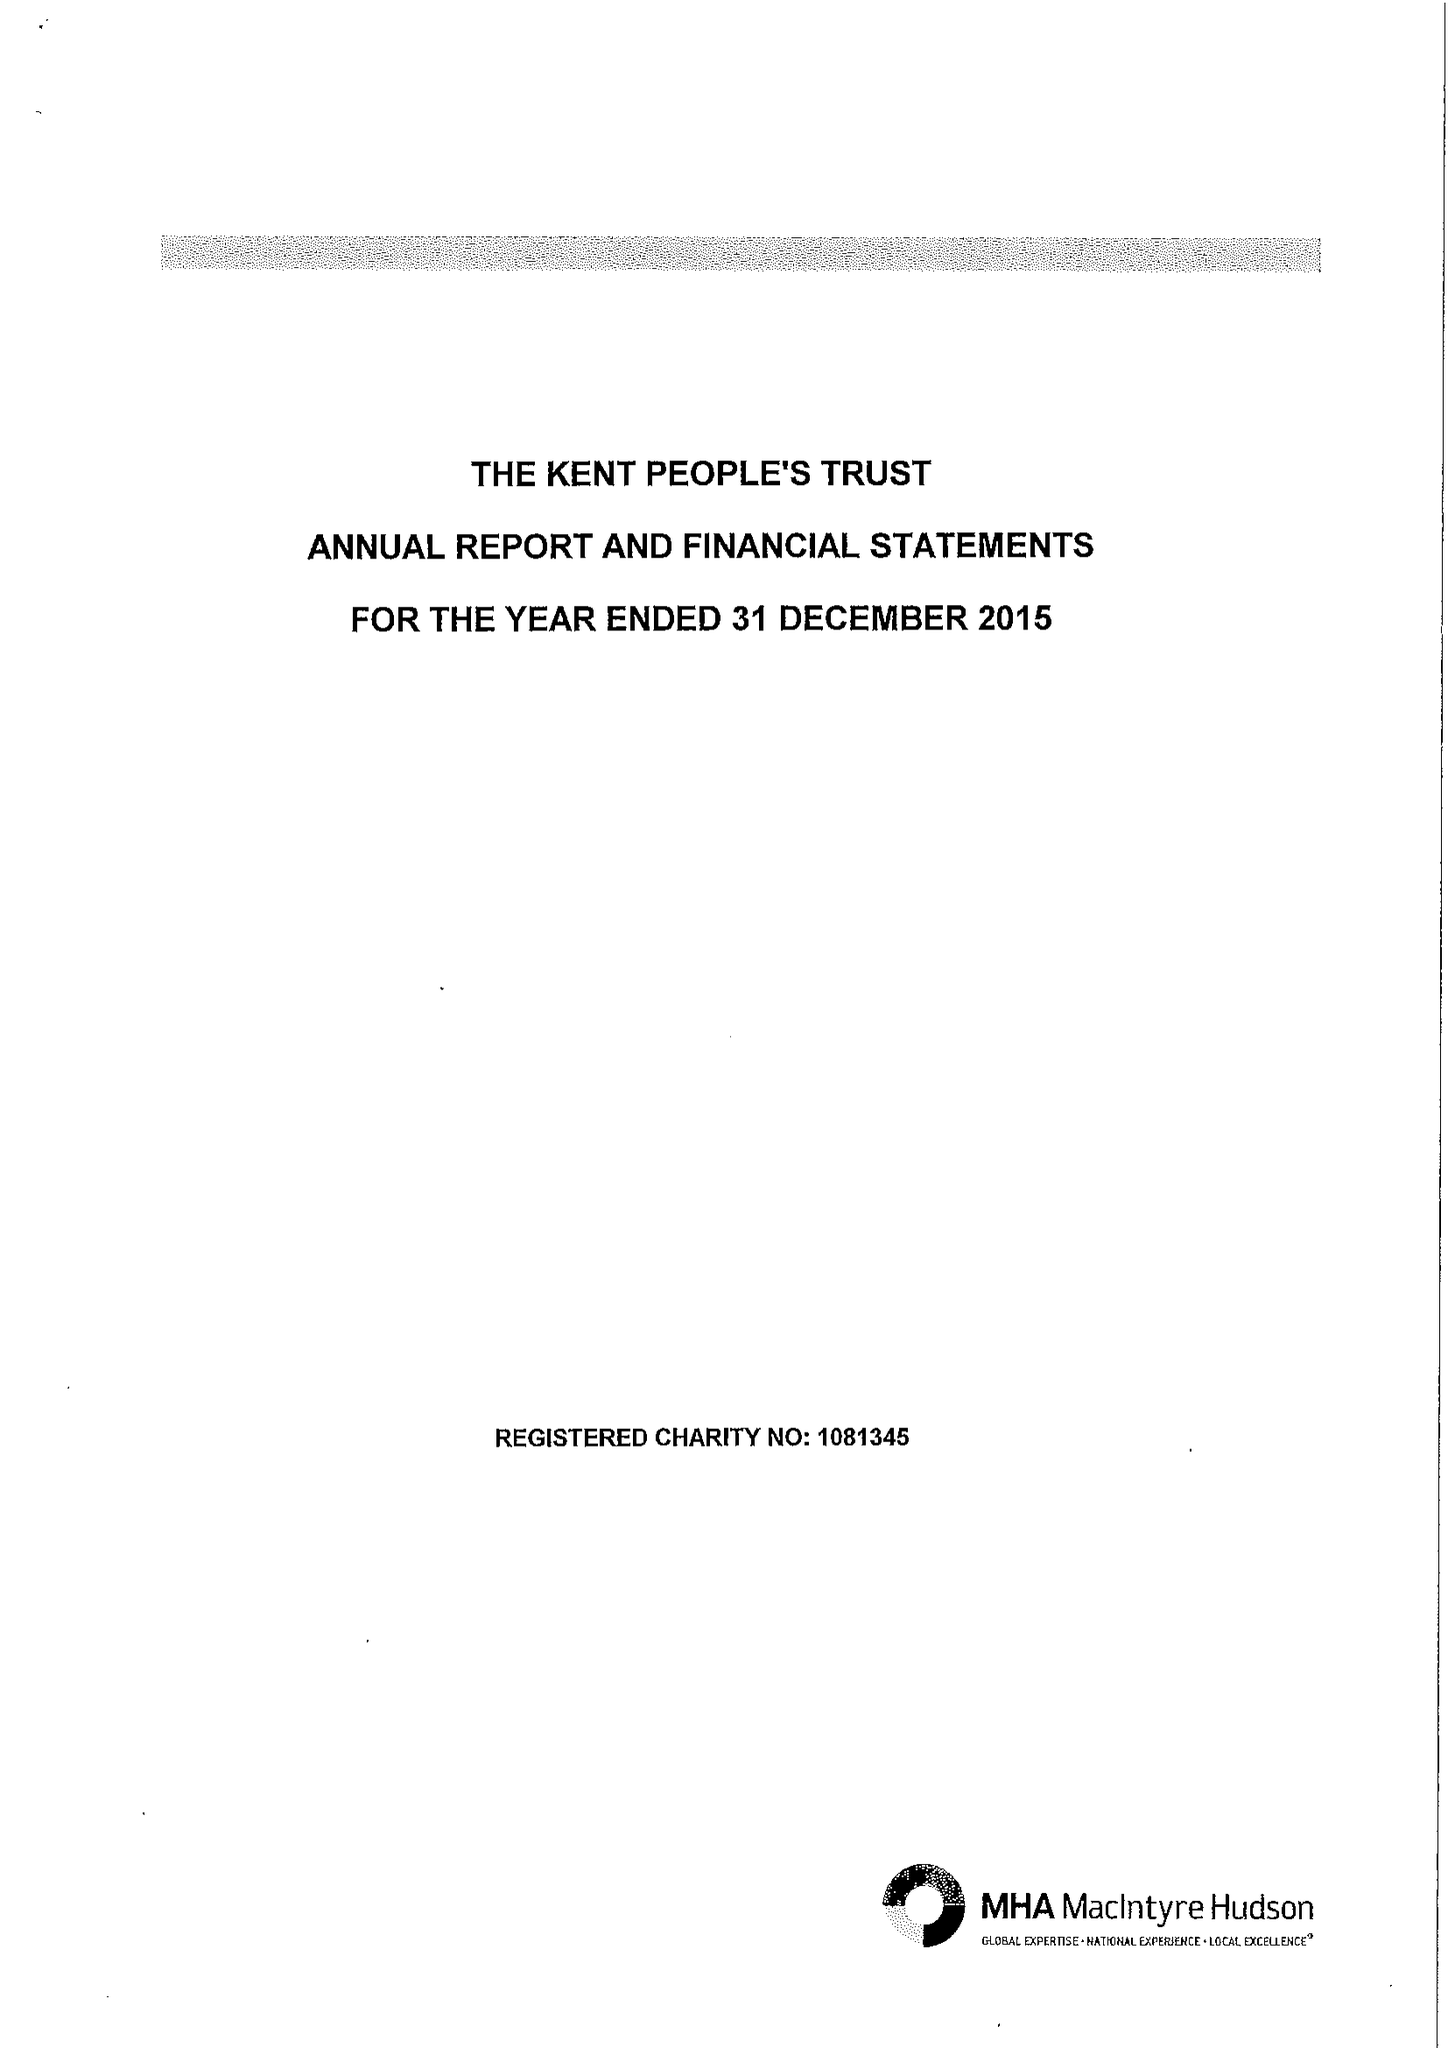What is the value for the charity_name?
Answer the question using a single word or phrase. The Kent People's Trust 